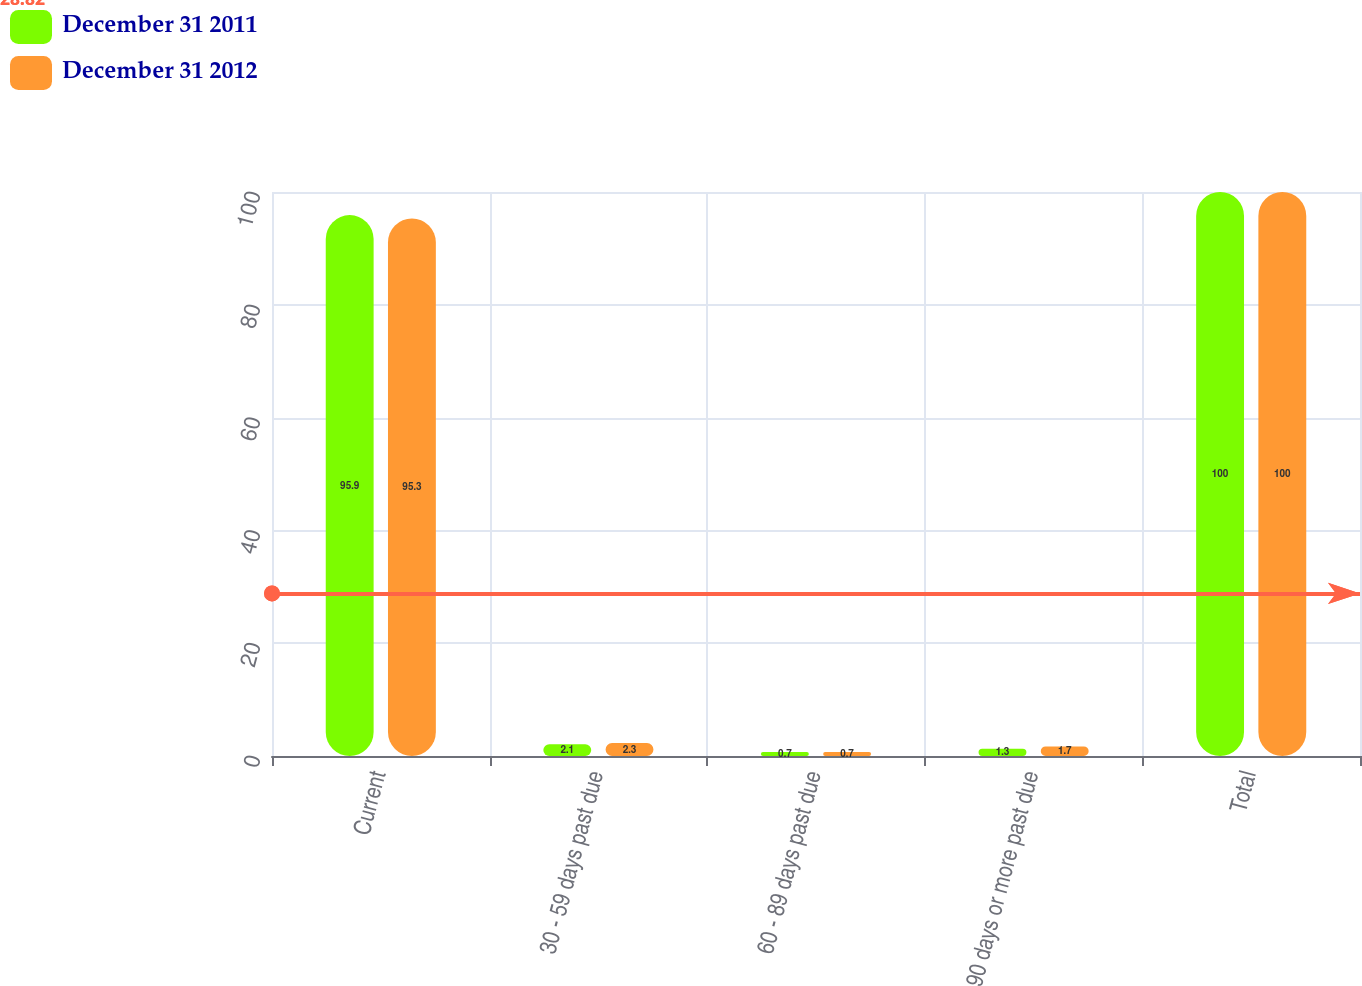Convert chart. <chart><loc_0><loc_0><loc_500><loc_500><stacked_bar_chart><ecel><fcel>Current<fcel>30 - 59 days past due<fcel>60 - 89 days past due<fcel>90 days or more past due<fcel>Total<nl><fcel>December 31 2011<fcel>95.9<fcel>2.1<fcel>0.7<fcel>1.3<fcel>100<nl><fcel>December 31 2012<fcel>95.3<fcel>2.3<fcel>0.7<fcel>1.7<fcel>100<nl></chart> 